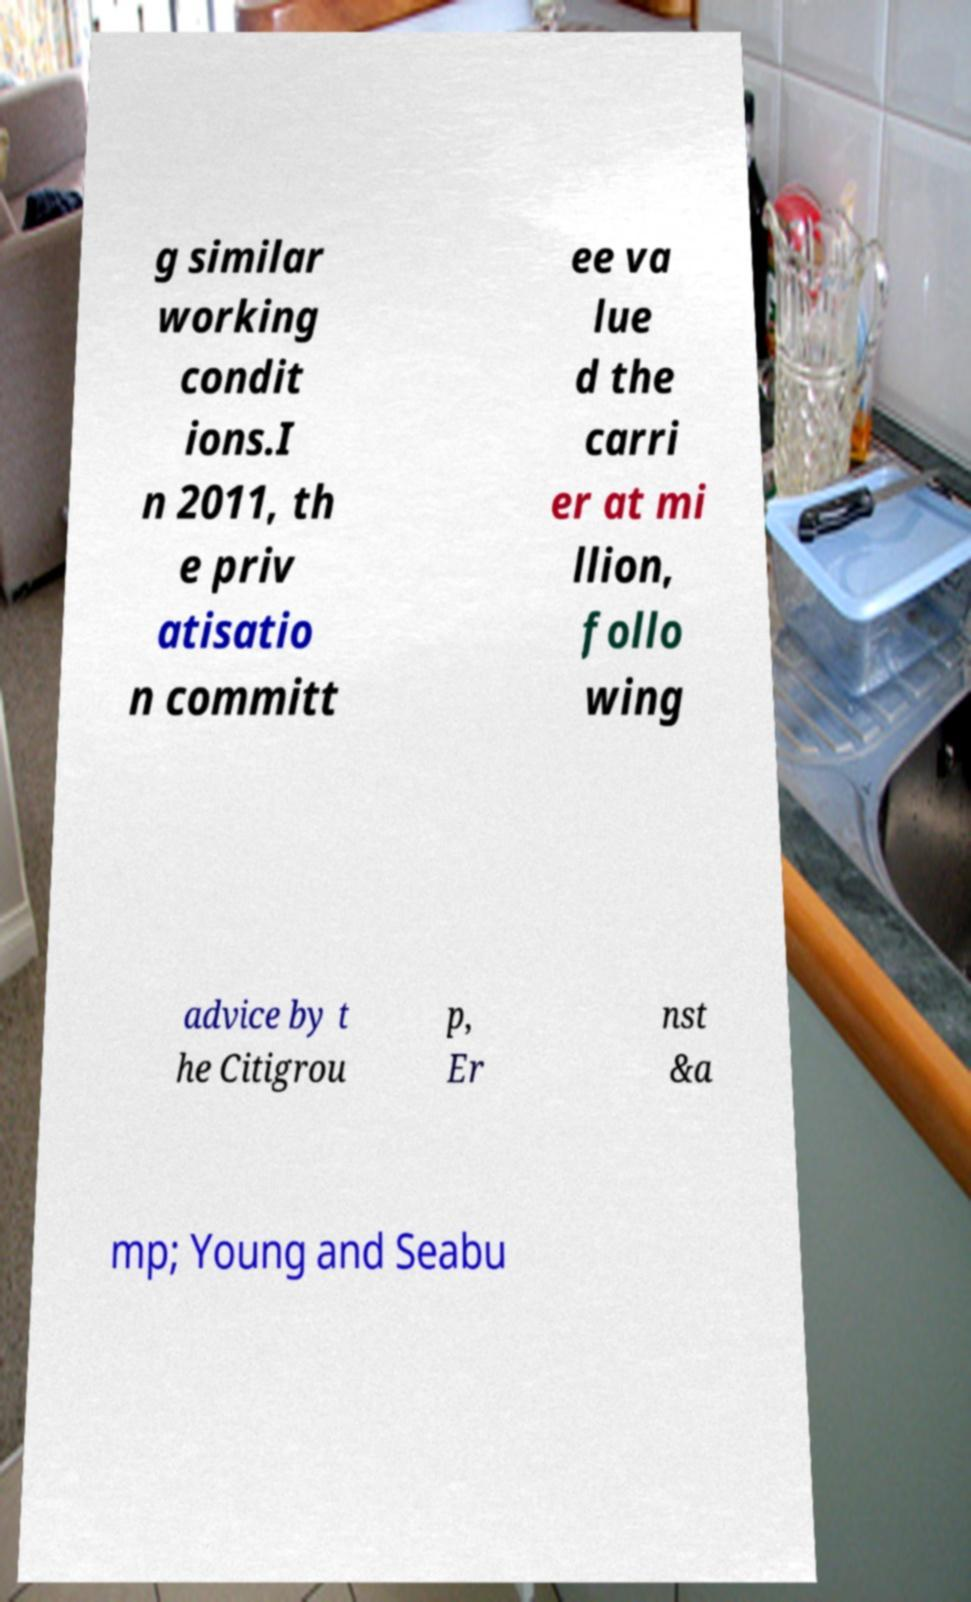There's text embedded in this image that I need extracted. Can you transcribe it verbatim? g similar working condit ions.I n 2011, th e priv atisatio n committ ee va lue d the carri er at mi llion, follo wing advice by t he Citigrou p, Er nst &a mp; Young and Seabu 